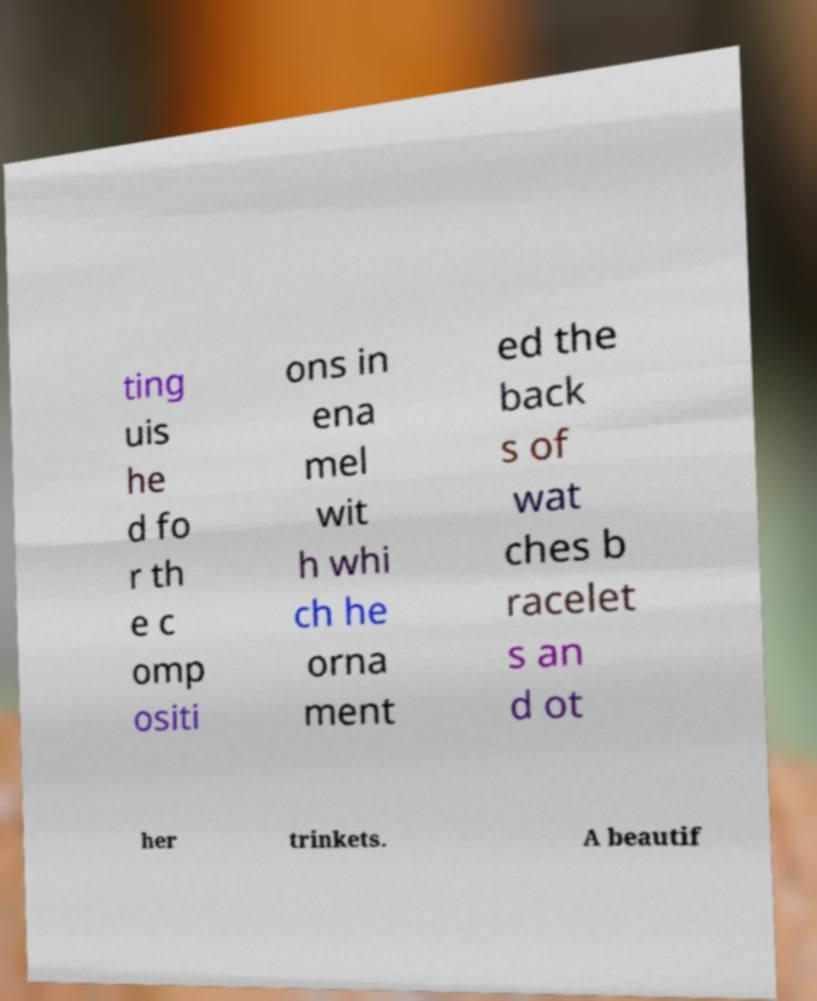Please read and relay the text visible in this image. What does it say? ting uis he d fo r th e c omp ositi ons in ena mel wit h whi ch he orna ment ed the back s of wat ches b racelet s an d ot her trinkets. A beautif 